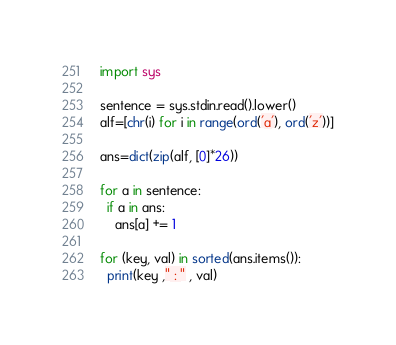<code> <loc_0><loc_0><loc_500><loc_500><_Python_>import sys

sentence = sys.stdin.read().lower()
alf=[chr(i) for i in range(ord('a'), ord('z'))]

ans=dict(zip(alf, [0]*26))

for a in sentence:
  if a in ans:
    ans[a] += 1

for (key, val) in sorted(ans.items()):
  print(key ," : " , val)</code> 